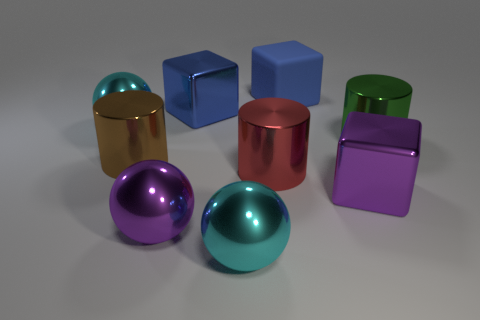Add 1 blue blocks. How many objects exist? 10 Subtract all cubes. How many objects are left? 6 Add 8 purple shiny cubes. How many purple shiny cubes exist? 9 Subtract 0 green blocks. How many objects are left? 9 Subtract all metal cylinders. Subtract all green cylinders. How many objects are left? 5 Add 5 big blocks. How many big blocks are left? 8 